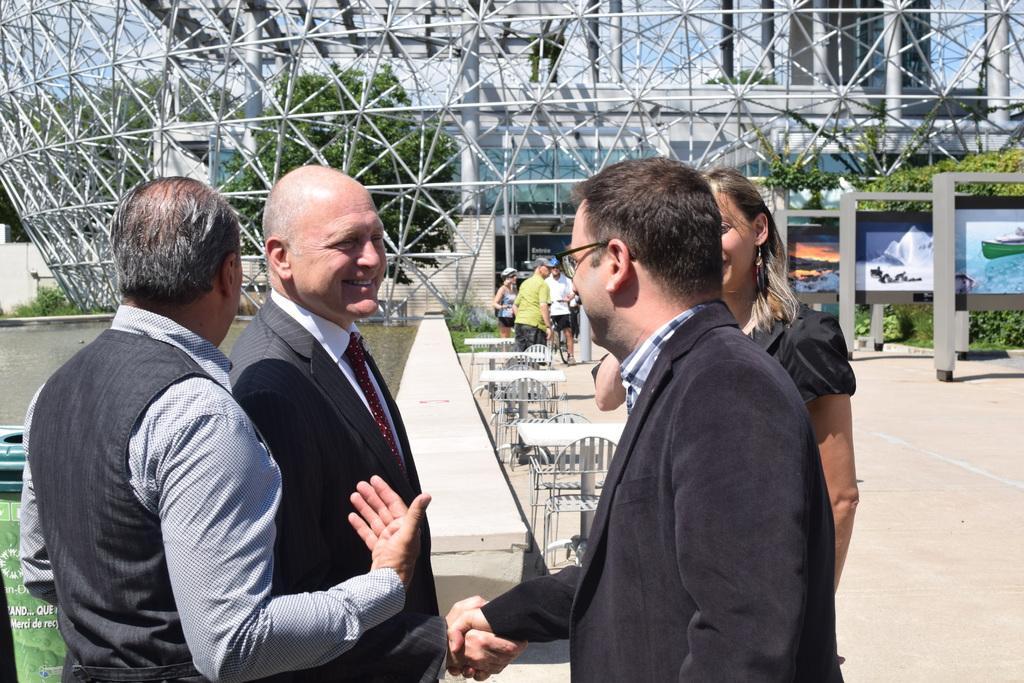Describe this image in one or two sentences. In the picture I can see people standing. I can see two people giving a shake hand. In the background, I can see people, tables, chairs and the building. 